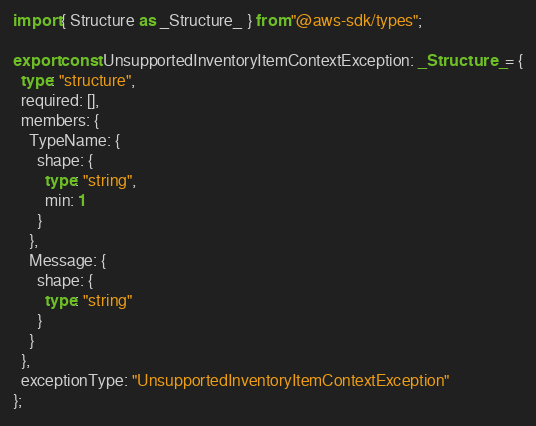<code> <loc_0><loc_0><loc_500><loc_500><_TypeScript_>import { Structure as _Structure_ } from "@aws-sdk/types";

export const UnsupportedInventoryItemContextException: _Structure_ = {
  type: "structure",
  required: [],
  members: {
    TypeName: {
      shape: {
        type: "string",
        min: 1
      }
    },
    Message: {
      shape: {
        type: "string"
      }
    }
  },
  exceptionType: "UnsupportedInventoryItemContextException"
};
</code> 